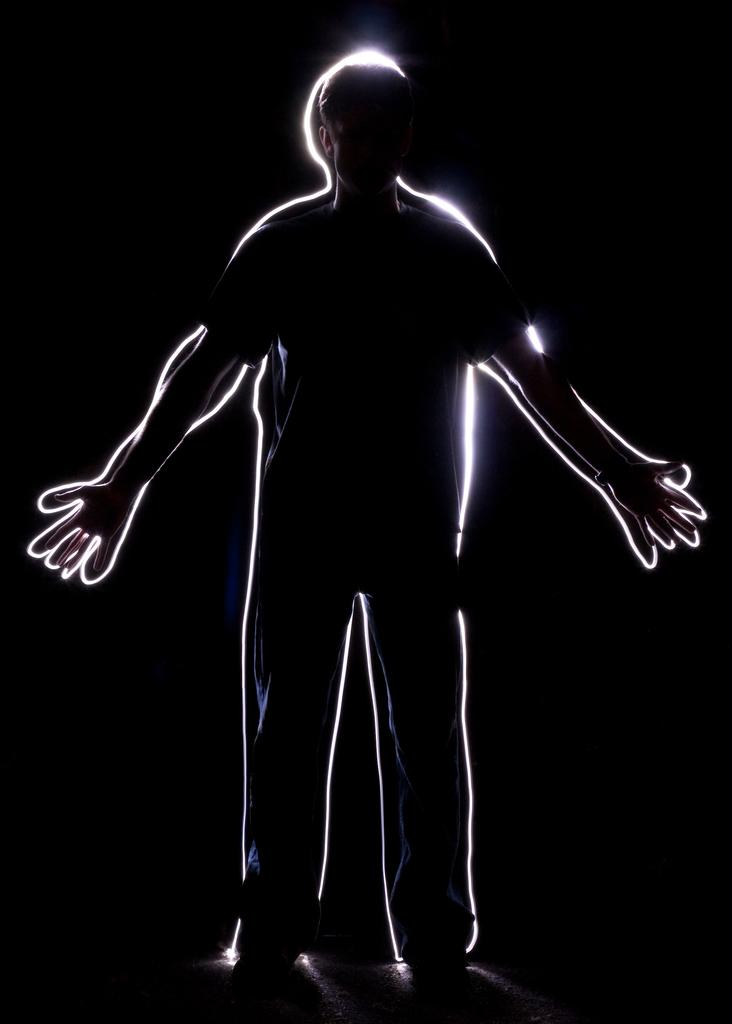What is the main subject of the image? There is a person standing in the image. What color is the background of the image? The background of the image is black in color. Is the person shaking a volcano in the image? There is no volcano present in the image, and the person is not shaking anything. 